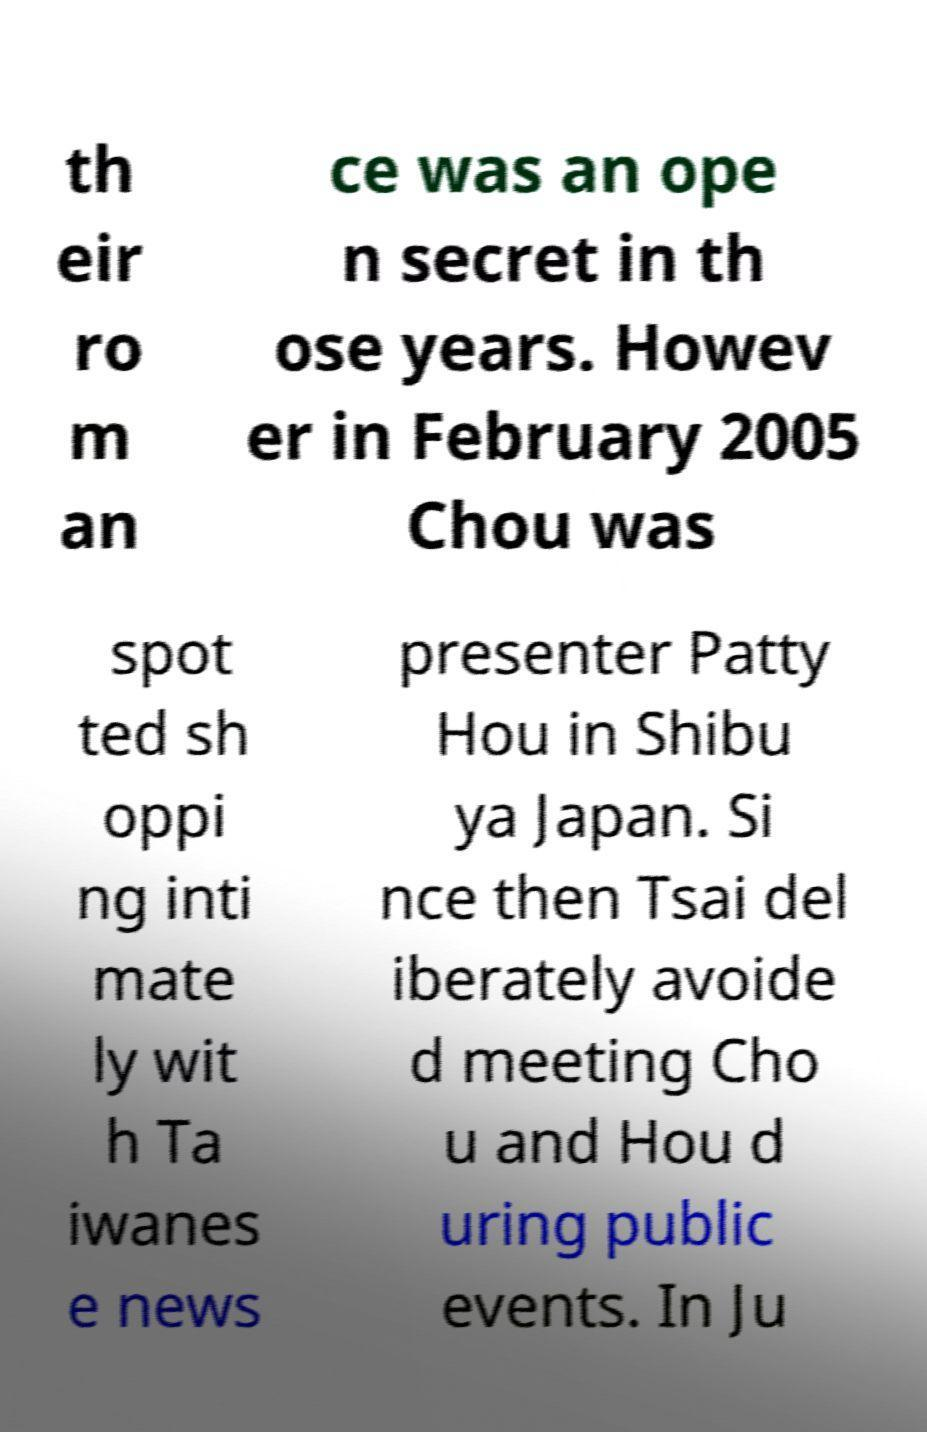Could you assist in decoding the text presented in this image and type it out clearly? th eir ro m an ce was an ope n secret in th ose years. Howev er in February 2005 Chou was spot ted sh oppi ng inti mate ly wit h Ta iwanes e news presenter Patty Hou in Shibu ya Japan. Si nce then Tsai del iberately avoide d meeting Cho u and Hou d uring public events. In Ju 